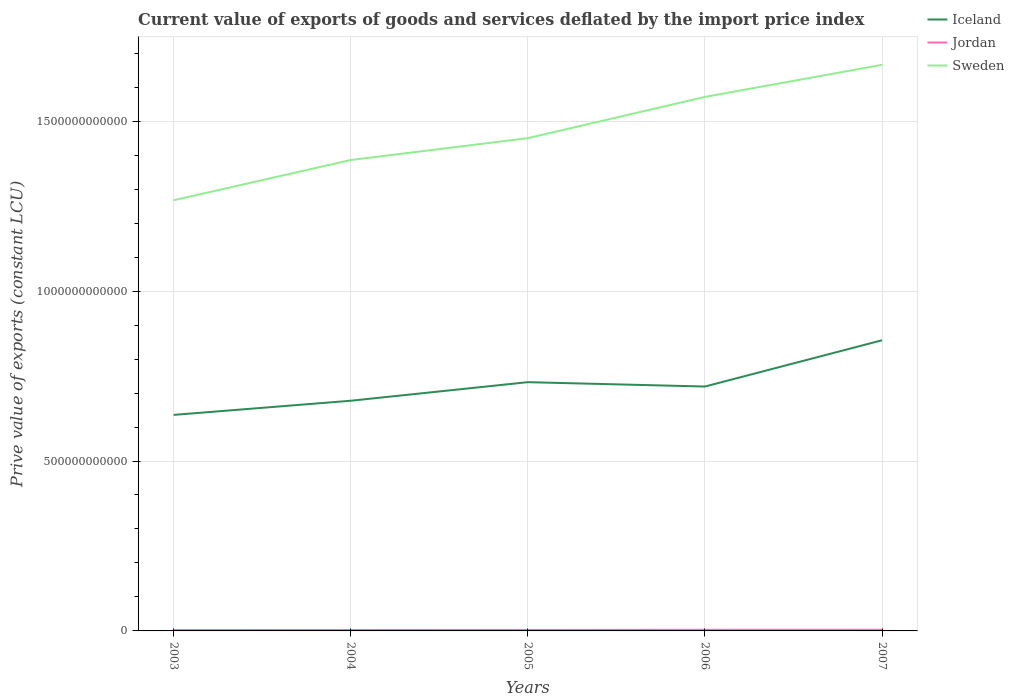Does the line corresponding to Iceland intersect with the line corresponding to Jordan?
Your response must be concise. No. Is the number of lines equal to the number of legend labels?
Provide a succinct answer. Yes. Across all years, what is the maximum prive value of exports in Iceland?
Your answer should be very brief. 6.36e+11. What is the total prive value of exports in Sweden in the graph?
Make the answer very short. -1.21e+11. What is the difference between the highest and the second highest prive value of exports in Jordan?
Provide a succinct answer. 8.33e+08. What is the difference between the highest and the lowest prive value of exports in Jordan?
Offer a terse response. 2. What is the difference between two consecutive major ticks on the Y-axis?
Give a very brief answer. 5.00e+11. Does the graph contain any zero values?
Ensure brevity in your answer.  No. Where does the legend appear in the graph?
Give a very brief answer. Top right. What is the title of the graph?
Offer a terse response. Current value of exports of goods and services deflated by the import price index. What is the label or title of the Y-axis?
Make the answer very short. Prive value of exports (constant LCU). What is the Prive value of exports (constant LCU) of Iceland in 2003?
Provide a succinct answer. 6.36e+11. What is the Prive value of exports (constant LCU) in Jordan in 2003?
Give a very brief answer. 2.56e+09. What is the Prive value of exports (constant LCU) in Sweden in 2003?
Ensure brevity in your answer.  1.27e+12. What is the Prive value of exports (constant LCU) of Iceland in 2004?
Your response must be concise. 6.77e+11. What is the Prive value of exports (constant LCU) in Jordan in 2004?
Provide a short and direct response. 2.82e+09. What is the Prive value of exports (constant LCU) of Sweden in 2004?
Provide a short and direct response. 1.39e+12. What is the Prive value of exports (constant LCU) of Iceland in 2005?
Provide a short and direct response. 7.32e+11. What is the Prive value of exports (constant LCU) of Jordan in 2005?
Ensure brevity in your answer.  2.92e+09. What is the Prive value of exports (constant LCU) of Sweden in 2005?
Offer a very short reply. 1.45e+12. What is the Prive value of exports (constant LCU) of Iceland in 2006?
Give a very brief answer. 7.19e+11. What is the Prive value of exports (constant LCU) in Jordan in 2006?
Offer a terse response. 3.31e+09. What is the Prive value of exports (constant LCU) in Sweden in 2006?
Make the answer very short. 1.57e+12. What is the Prive value of exports (constant LCU) of Iceland in 2007?
Provide a succinct answer. 8.55e+11. What is the Prive value of exports (constant LCU) of Jordan in 2007?
Offer a terse response. 3.39e+09. What is the Prive value of exports (constant LCU) of Sweden in 2007?
Your response must be concise. 1.67e+12. Across all years, what is the maximum Prive value of exports (constant LCU) of Iceland?
Keep it short and to the point. 8.55e+11. Across all years, what is the maximum Prive value of exports (constant LCU) of Jordan?
Provide a short and direct response. 3.39e+09. Across all years, what is the maximum Prive value of exports (constant LCU) in Sweden?
Give a very brief answer. 1.67e+12. Across all years, what is the minimum Prive value of exports (constant LCU) in Iceland?
Your response must be concise. 6.36e+11. Across all years, what is the minimum Prive value of exports (constant LCU) of Jordan?
Offer a very short reply. 2.56e+09. Across all years, what is the minimum Prive value of exports (constant LCU) of Sweden?
Make the answer very short. 1.27e+12. What is the total Prive value of exports (constant LCU) in Iceland in the graph?
Keep it short and to the point. 3.62e+12. What is the total Prive value of exports (constant LCU) of Jordan in the graph?
Make the answer very short. 1.50e+1. What is the total Prive value of exports (constant LCU) of Sweden in the graph?
Offer a very short reply. 7.34e+12. What is the difference between the Prive value of exports (constant LCU) in Iceland in 2003 and that in 2004?
Keep it short and to the point. -4.17e+1. What is the difference between the Prive value of exports (constant LCU) of Jordan in 2003 and that in 2004?
Your answer should be very brief. -2.58e+08. What is the difference between the Prive value of exports (constant LCU) of Sweden in 2003 and that in 2004?
Offer a terse response. -1.18e+11. What is the difference between the Prive value of exports (constant LCU) in Iceland in 2003 and that in 2005?
Provide a succinct answer. -9.63e+1. What is the difference between the Prive value of exports (constant LCU) of Jordan in 2003 and that in 2005?
Provide a short and direct response. -3.55e+08. What is the difference between the Prive value of exports (constant LCU) of Sweden in 2003 and that in 2005?
Keep it short and to the point. -1.83e+11. What is the difference between the Prive value of exports (constant LCU) in Iceland in 2003 and that in 2006?
Your answer should be very brief. -8.35e+1. What is the difference between the Prive value of exports (constant LCU) of Jordan in 2003 and that in 2006?
Ensure brevity in your answer.  -7.46e+08. What is the difference between the Prive value of exports (constant LCU) in Sweden in 2003 and that in 2006?
Your answer should be very brief. -3.04e+11. What is the difference between the Prive value of exports (constant LCU) of Iceland in 2003 and that in 2007?
Your answer should be compact. -2.20e+11. What is the difference between the Prive value of exports (constant LCU) in Jordan in 2003 and that in 2007?
Your response must be concise. -8.33e+08. What is the difference between the Prive value of exports (constant LCU) in Sweden in 2003 and that in 2007?
Your answer should be compact. -3.98e+11. What is the difference between the Prive value of exports (constant LCU) in Iceland in 2004 and that in 2005?
Provide a succinct answer. -5.47e+1. What is the difference between the Prive value of exports (constant LCU) in Jordan in 2004 and that in 2005?
Make the answer very short. -9.74e+07. What is the difference between the Prive value of exports (constant LCU) in Sweden in 2004 and that in 2005?
Make the answer very short. -6.43e+1. What is the difference between the Prive value of exports (constant LCU) in Iceland in 2004 and that in 2006?
Offer a very short reply. -4.18e+1. What is the difference between the Prive value of exports (constant LCU) in Jordan in 2004 and that in 2006?
Offer a very short reply. -4.88e+08. What is the difference between the Prive value of exports (constant LCU) of Sweden in 2004 and that in 2006?
Give a very brief answer. -1.86e+11. What is the difference between the Prive value of exports (constant LCU) in Iceland in 2004 and that in 2007?
Your answer should be compact. -1.78e+11. What is the difference between the Prive value of exports (constant LCU) in Jordan in 2004 and that in 2007?
Provide a short and direct response. -5.75e+08. What is the difference between the Prive value of exports (constant LCU) of Sweden in 2004 and that in 2007?
Your answer should be very brief. -2.80e+11. What is the difference between the Prive value of exports (constant LCU) of Iceland in 2005 and that in 2006?
Your response must be concise. 1.28e+1. What is the difference between the Prive value of exports (constant LCU) of Jordan in 2005 and that in 2006?
Keep it short and to the point. -3.91e+08. What is the difference between the Prive value of exports (constant LCU) in Sweden in 2005 and that in 2006?
Your answer should be compact. -1.21e+11. What is the difference between the Prive value of exports (constant LCU) of Iceland in 2005 and that in 2007?
Give a very brief answer. -1.23e+11. What is the difference between the Prive value of exports (constant LCU) of Jordan in 2005 and that in 2007?
Ensure brevity in your answer.  -4.77e+08. What is the difference between the Prive value of exports (constant LCU) in Sweden in 2005 and that in 2007?
Make the answer very short. -2.16e+11. What is the difference between the Prive value of exports (constant LCU) in Iceland in 2006 and that in 2007?
Give a very brief answer. -1.36e+11. What is the difference between the Prive value of exports (constant LCU) in Jordan in 2006 and that in 2007?
Offer a very short reply. -8.67e+07. What is the difference between the Prive value of exports (constant LCU) of Sweden in 2006 and that in 2007?
Offer a very short reply. -9.44e+1. What is the difference between the Prive value of exports (constant LCU) in Iceland in 2003 and the Prive value of exports (constant LCU) in Jordan in 2004?
Your response must be concise. 6.33e+11. What is the difference between the Prive value of exports (constant LCU) of Iceland in 2003 and the Prive value of exports (constant LCU) of Sweden in 2004?
Ensure brevity in your answer.  -7.50e+11. What is the difference between the Prive value of exports (constant LCU) in Jordan in 2003 and the Prive value of exports (constant LCU) in Sweden in 2004?
Offer a very short reply. -1.38e+12. What is the difference between the Prive value of exports (constant LCU) of Iceland in 2003 and the Prive value of exports (constant LCU) of Jordan in 2005?
Your answer should be very brief. 6.33e+11. What is the difference between the Prive value of exports (constant LCU) of Iceland in 2003 and the Prive value of exports (constant LCU) of Sweden in 2005?
Provide a succinct answer. -8.14e+11. What is the difference between the Prive value of exports (constant LCU) in Jordan in 2003 and the Prive value of exports (constant LCU) in Sweden in 2005?
Provide a succinct answer. -1.45e+12. What is the difference between the Prive value of exports (constant LCU) in Iceland in 2003 and the Prive value of exports (constant LCU) in Jordan in 2006?
Keep it short and to the point. 6.32e+11. What is the difference between the Prive value of exports (constant LCU) of Iceland in 2003 and the Prive value of exports (constant LCU) of Sweden in 2006?
Keep it short and to the point. -9.36e+11. What is the difference between the Prive value of exports (constant LCU) in Jordan in 2003 and the Prive value of exports (constant LCU) in Sweden in 2006?
Provide a short and direct response. -1.57e+12. What is the difference between the Prive value of exports (constant LCU) of Iceland in 2003 and the Prive value of exports (constant LCU) of Jordan in 2007?
Your answer should be very brief. 6.32e+11. What is the difference between the Prive value of exports (constant LCU) in Iceland in 2003 and the Prive value of exports (constant LCU) in Sweden in 2007?
Provide a succinct answer. -1.03e+12. What is the difference between the Prive value of exports (constant LCU) in Jordan in 2003 and the Prive value of exports (constant LCU) in Sweden in 2007?
Offer a terse response. -1.66e+12. What is the difference between the Prive value of exports (constant LCU) of Iceland in 2004 and the Prive value of exports (constant LCU) of Jordan in 2005?
Ensure brevity in your answer.  6.74e+11. What is the difference between the Prive value of exports (constant LCU) in Iceland in 2004 and the Prive value of exports (constant LCU) in Sweden in 2005?
Give a very brief answer. -7.73e+11. What is the difference between the Prive value of exports (constant LCU) in Jordan in 2004 and the Prive value of exports (constant LCU) in Sweden in 2005?
Your answer should be compact. -1.45e+12. What is the difference between the Prive value of exports (constant LCU) of Iceland in 2004 and the Prive value of exports (constant LCU) of Jordan in 2006?
Offer a very short reply. 6.74e+11. What is the difference between the Prive value of exports (constant LCU) in Iceland in 2004 and the Prive value of exports (constant LCU) in Sweden in 2006?
Provide a succinct answer. -8.94e+11. What is the difference between the Prive value of exports (constant LCU) in Jordan in 2004 and the Prive value of exports (constant LCU) in Sweden in 2006?
Offer a very short reply. -1.57e+12. What is the difference between the Prive value of exports (constant LCU) of Iceland in 2004 and the Prive value of exports (constant LCU) of Jordan in 2007?
Your answer should be very brief. 6.74e+11. What is the difference between the Prive value of exports (constant LCU) of Iceland in 2004 and the Prive value of exports (constant LCU) of Sweden in 2007?
Your answer should be very brief. -9.89e+11. What is the difference between the Prive value of exports (constant LCU) of Jordan in 2004 and the Prive value of exports (constant LCU) of Sweden in 2007?
Give a very brief answer. -1.66e+12. What is the difference between the Prive value of exports (constant LCU) of Iceland in 2005 and the Prive value of exports (constant LCU) of Jordan in 2006?
Keep it short and to the point. 7.29e+11. What is the difference between the Prive value of exports (constant LCU) of Iceland in 2005 and the Prive value of exports (constant LCU) of Sweden in 2006?
Make the answer very short. -8.39e+11. What is the difference between the Prive value of exports (constant LCU) of Jordan in 2005 and the Prive value of exports (constant LCU) of Sweden in 2006?
Offer a terse response. -1.57e+12. What is the difference between the Prive value of exports (constant LCU) in Iceland in 2005 and the Prive value of exports (constant LCU) in Jordan in 2007?
Your response must be concise. 7.29e+11. What is the difference between the Prive value of exports (constant LCU) in Iceland in 2005 and the Prive value of exports (constant LCU) in Sweden in 2007?
Your answer should be very brief. -9.34e+11. What is the difference between the Prive value of exports (constant LCU) of Jordan in 2005 and the Prive value of exports (constant LCU) of Sweden in 2007?
Your answer should be very brief. -1.66e+12. What is the difference between the Prive value of exports (constant LCU) in Iceland in 2006 and the Prive value of exports (constant LCU) in Jordan in 2007?
Your answer should be compact. 7.16e+11. What is the difference between the Prive value of exports (constant LCU) in Iceland in 2006 and the Prive value of exports (constant LCU) in Sweden in 2007?
Keep it short and to the point. -9.47e+11. What is the difference between the Prive value of exports (constant LCU) of Jordan in 2006 and the Prive value of exports (constant LCU) of Sweden in 2007?
Offer a very short reply. -1.66e+12. What is the average Prive value of exports (constant LCU) in Iceland per year?
Your answer should be compact. 7.24e+11. What is the average Prive value of exports (constant LCU) in Jordan per year?
Your answer should be very brief. 3.00e+09. What is the average Prive value of exports (constant LCU) of Sweden per year?
Keep it short and to the point. 1.47e+12. In the year 2003, what is the difference between the Prive value of exports (constant LCU) of Iceland and Prive value of exports (constant LCU) of Jordan?
Keep it short and to the point. 6.33e+11. In the year 2003, what is the difference between the Prive value of exports (constant LCU) of Iceland and Prive value of exports (constant LCU) of Sweden?
Give a very brief answer. -6.32e+11. In the year 2003, what is the difference between the Prive value of exports (constant LCU) of Jordan and Prive value of exports (constant LCU) of Sweden?
Make the answer very short. -1.26e+12. In the year 2004, what is the difference between the Prive value of exports (constant LCU) of Iceland and Prive value of exports (constant LCU) of Jordan?
Your answer should be compact. 6.75e+11. In the year 2004, what is the difference between the Prive value of exports (constant LCU) in Iceland and Prive value of exports (constant LCU) in Sweden?
Provide a succinct answer. -7.08e+11. In the year 2004, what is the difference between the Prive value of exports (constant LCU) in Jordan and Prive value of exports (constant LCU) in Sweden?
Your response must be concise. -1.38e+12. In the year 2005, what is the difference between the Prive value of exports (constant LCU) of Iceland and Prive value of exports (constant LCU) of Jordan?
Offer a terse response. 7.29e+11. In the year 2005, what is the difference between the Prive value of exports (constant LCU) of Iceland and Prive value of exports (constant LCU) of Sweden?
Make the answer very short. -7.18e+11. In the year 2005, what is the difference between the Prive value of exports (constant LCU) of Jordan and Prive value of exports (constant LCU) of Sweden?
Your answer should be compact. -1.45e+12. In the year 2006, what is the difference between the Prive value of exports (constant LCU) of Iceland and Prive value of exports (constant LCU) of Jordan?
Provide a succinct answer. 7.16e+11. In the year 2006, what is the difference between the Prive value of exports (constant LCU) of Iceland and Prive value of exports (constant LCU) of Sweden?
Give a very brief answer. -8.52e+11. In the year 2006, what is the difference between the Prive value of exports (constant LCU) in Jordan and Prive value of exports (constant LCU) in Sweden?
Offer a terse response. -1.57e+12. In the year 2007, what is the difference between the Prive value of exports (constant LCU) of Iceland and Prive value of exports (constant LCU) of Jordan?
Your answer should be very brief. 8.52e+11. In the year 2007, what is the difference between the Prive value of exports (constant LCU) in Iceland and Prive value of exports (constant LCU) in Sweden?
Provide a succinct answer. -8.11e+11. In the year 2007, what is the difference between the Prive value of exports (constant LCU) in Jordan and Prive value of exports (constant LCU) in Sweden?
Provide a short and direct response. -1.66e+12. What is the ratio of the Prive value of exports (constant LCU) of Iceland in 2003 to that in 2004?
Make the answer very short. 0.94. What is the ratio of the Prive value of exports (constant LCU) of Jordan in 2003 to that in 2004?
Keep it short and to the point. 0.91. What is the ratio of the Prive value of exports (constant LCU) in Sweden in 2003 to that in 2004?
Give a very brief answer. 0.91. What is the ratio of the Prive value of exports (constant LCU) of Iceland in 2003 to that in 2005?
Offer a very short reply. 0.87. What is the ratio of the Prive value of exports (constant LCU) in Jordan in 2003 to that in 2005?
Ensure brevity in your answer.  0.88. What is the ratio of the Prive value of exports (constant LCU) in Sweden in 2003 to that in 2005?
Offer a very short reply. 0.87. What is the ratio of the Prive value of exports (constant LCU) of Iceland in 2003 to that in 2006?
Provide a short and direct response. 0.88. What is the ratio of the Prive value of exports (constant LCU) of Jordan in 2003 to that in 2006?
Give a very brief answer. 0.77. What is the ratio of the Prive value of exports (constant LCU) in Sweden in 2003 to that in 2006?
Keep it short and to the point. 0.81. What is the ratio of the Prive value of exports (constant LCU) of Iceland in 2003 to that in 2007?
Your answer should be very brief. 0.74. What is the ratio of the Prive value of exports (constant LCU) in Jordan in 2003 to that in 2007?
Your response must be concise. 0.75. What is the ratio of the Prive value of exports (constant LCU) of Sweden in 2003 to that in 2007?
Your response must be concise. 0.76. What is the ratio of the Prive value of exports (constant LCU) of Iceland in 2004 to that in 2005?
Provide a short and direct response. 0.93. What is the ratio of the Prive value of exports (constant LCU) in Jordan in 2004 to that in 2005?
Provide a short and direct response. 0.97. What is the ratio of the Prive value of exports (constant LCU) of Sweden in 2004 to that in 2005?
Make the answer very short. 0.96. What is the ratio of the Prive value of exports (constant LCU) of Iceland in 2004 to that in 2006?
Your answer should be very brief. 0.94. What is the ratio of the Prive value of exports (constant LCU) of Jordan in 2004 to that in 2006?
Your answer should be very brief. 0.85. What is the ratio of the Prive value of exports (constant LCU) of Sweden in 2004 to that in 2006?
Make the answer very short. 0.88. What is the ratio of the Prive value of exports (constant LCU) of Iceland in 2004 to that in 2007?
Give a very brief answer. 0.79. What is the ratio of the Prive value of exports (constant LCU) of Jordan in 2004 to that in 2007?
Keep it short and to the point. 0.83. What is the ratio of the Prive value of exports (constant LCU) of Sweden in 2004 to that in 2007?
Give a very brief answer. 0.83. What is the ratio of the Prive value of exports (constant LCU) in Iceland in 2005 to that in 2006?
Provide a short and direct response. 1.02. What is the ratio of the Prive value of exports (constant LCU) in Jordan in 2005 to that in 2006?
Offer a terse response. 0.88. What is the ratio of the Prive value of exports (constant LCU) of Sweden in 2005 to that in 2006?
Give a very brief answer. 0.92. What is the ratio of the Prive value of exports (constant LCU) of Iceland in 2005 to that in 2007?
Your answer should be very brief. 0.86. What is the ratio of the Prive value of exports (constant LCU) of Jordan in 2005 to that in 2007?
Provide a short and direct response. 0.86. What is the ratio of the Prive value of exports (constant LCU) in Sweden in 2005 to that in 2007?
Provide a succinct answer. 0.87. What is the ratio of the Prive value of exports (constant LCU) of Iceland in 2006 to that in 2007?
Ensure brevity in your answer.  0.84. What is the ratio of the Prive value of exports (constant LCU) in Jordan in 2006 to that in 2007?
Keep it short and to the point. 0.97. What is the ratio of the Prive value of exports (constant LCU) of Sweden in 2006 to that in 2007?
Offer a terse response. 0.94. What is the difference between the highest and the second highest Prive value of exports (constant LCU) of Iceland?
Your answer should be very brief. 1.23e+11. What is the difference between the highest and the second highest Prive value of exports (constant LCU) of Jordan?
Your answer should be compact. 8.67e+07. What is the difference between the highest and the second highest Prive value of exports (constant LCU) in Sweden?
Offer a terse response. 9.44e+1. What is the difference between the highest and the lowest Prive value of exports (constant LCU) in Iceland?
Keep it short and to the point. 2.20e+11. What is the difference between the highest and the lowest Prive value of exports (constant LCU) of Jordan?
Your answer should be compact. 8.33e+08. What is the difference between the highest and the lowest Prive value of exports (constant LCU) in Sweden?
Offer a very short reply. 3.98e+11. 